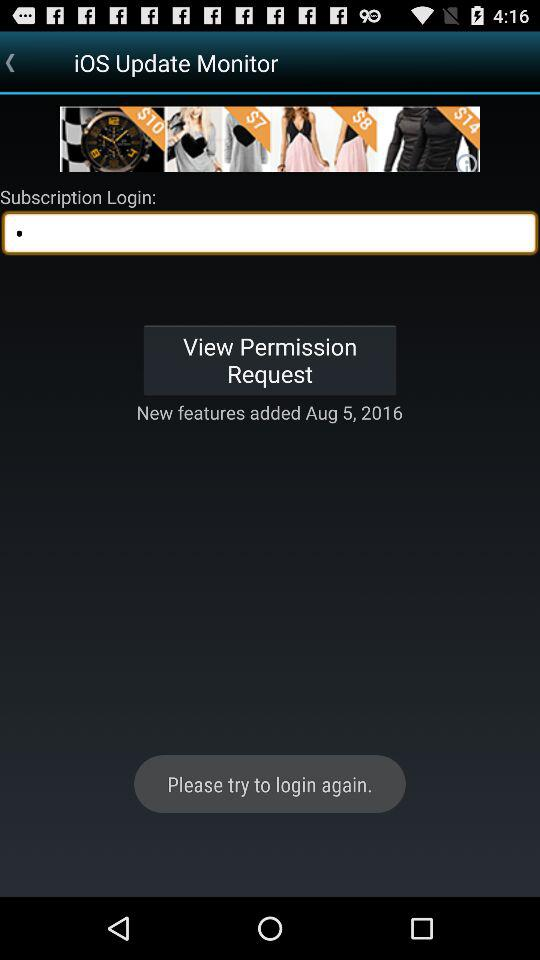When were the new features added? The new features were added on August 5, 2016. 